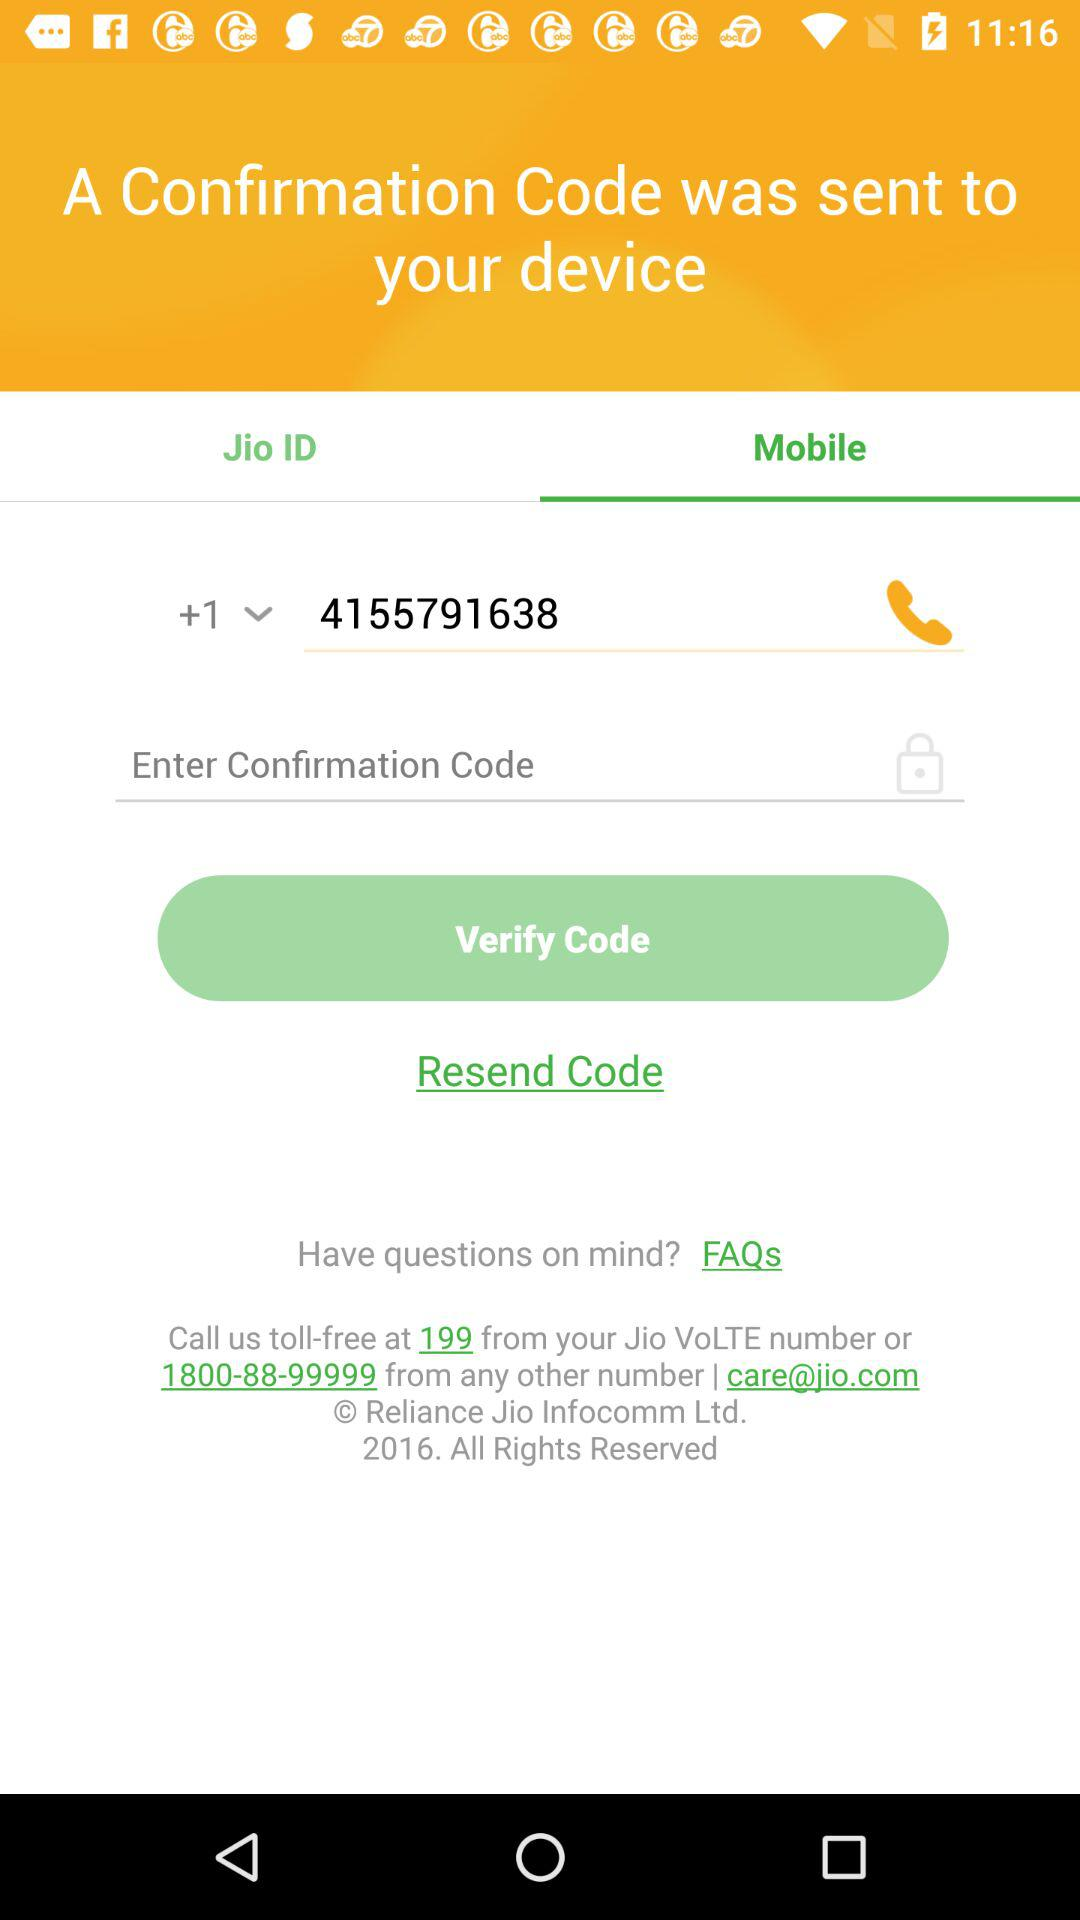What is the phone number to which the confirmation code was sent? The phone number is +1 4155791638. 